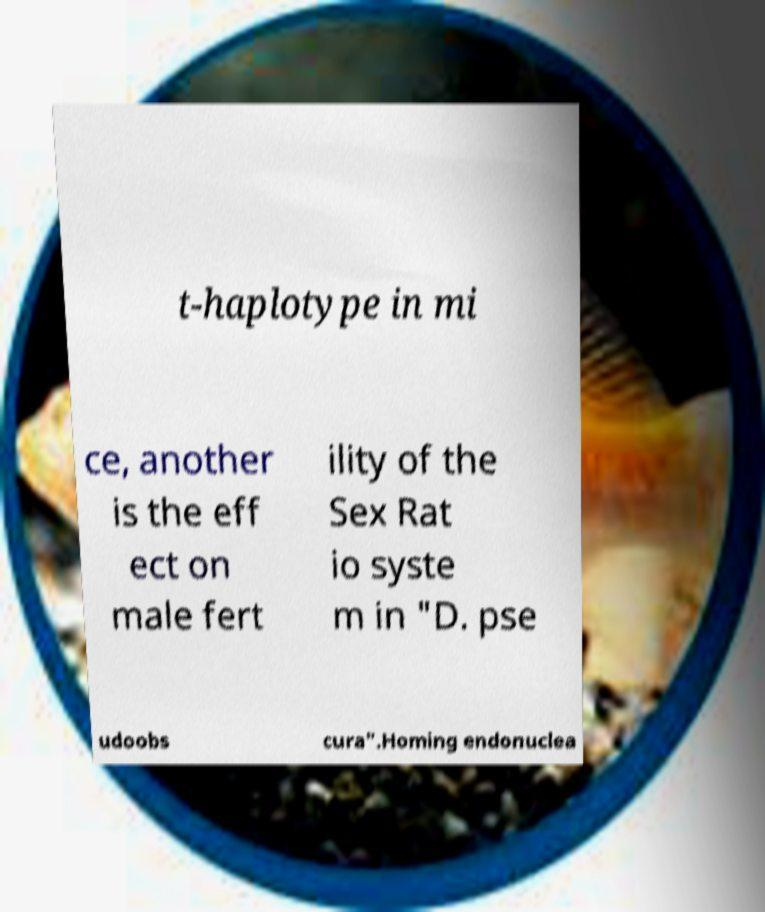Please read and relay the text visible in this image. What does it say? t-haplotype in mi ce, another is the eff ect on male fert ility of the Sex Rat io syste m in "D. pse udoobs cura".Homing endonuclea 